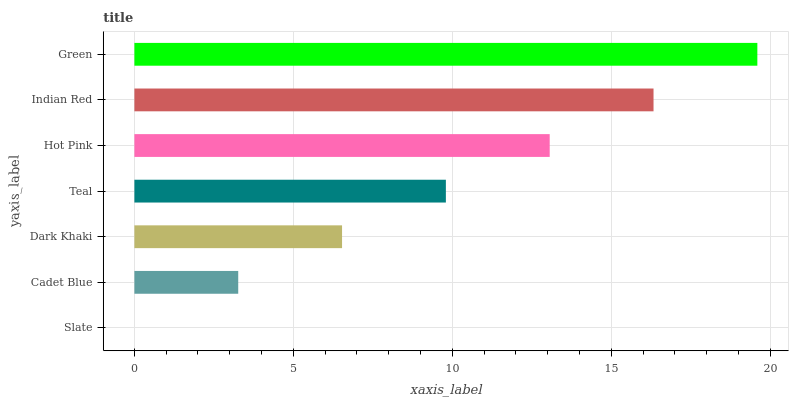Is Slate the minimum?
Answer yes or no. Yes. Is Green the maximum?
Answer yes or no. Yes. Is Cadet Blue the minimum?
Answer yes or no. No. Is Cadet Blue the maximum?
Answer yes or no. No. Is Cadet Blue greater than Slate?
Answer yes or no. Yes. Is Slate less than Cadet Blue?
Answer yes or no. Yes. Is Slate greater than Cadet Blue?
Answer yes or no. No. Is Cadet Blue less than Slate?
Answer yes or no. No. Is Teal the high median?
Answer yes or no. Yes. Is Teal the low median?
Answer yes or no. Yes. Is Hot Pink the high median?
Answer yes or no. No. Is Cadet Blue the low median?
Answer yes or no. No. 